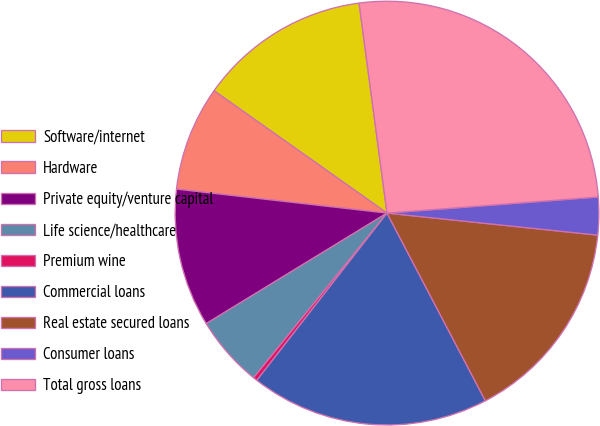Convert chart. <chart><loc_0><loc_0><loc_500><loc_500><pie_chart><fcel>Software/internet<fcel>Hardware<fcel>Private equity/venture capital<fcel>Life science/healthcare<fcel>Premium wine<fcel>Commercial loans<fcel>Real estate secured loans<fcel>Consumer loans<fcel>Total gross loans<nl><fcel>13.1%<fcel>7.99%<fcel>10.54%<fcel>5.43%<fcel>0.31%<fcel>18.21%<fcel>15.66%<fcel>2.87%<fcel>25.89%<nl></chart> 